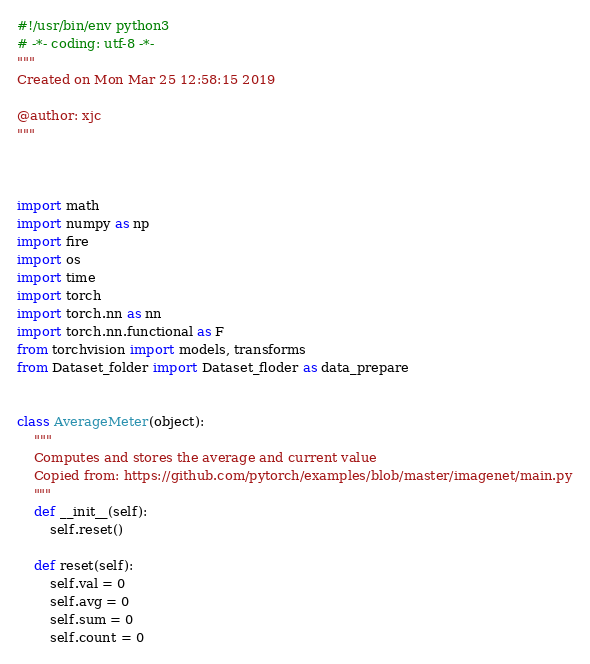<code> <loc_0><loc_0><loc_500><loc_500><_Python_>#!/usr/bin/env python3
# -*- coding: utf-8 -*-
"""
Created on Mon Mar 25 12:58:15 2019

@author: xjc
"""



import math
import numpy as np
import fire
import os
import time
import torch
import torch.nn as nn
import torch.nn.functional as F
from torchvision import models, transforms
from Dataset_folder import Dataset_floder as data_prepare


class AverageMeter(object):
    """
    Computes and stores the average and current value
    Copied from: https://github.com/pytorch/examples/blob/master/imagenet/main.py
    """
    def __init__(self):
        self.reset()

    def reset(self):
        self.val = 0
        self.avg = 0
        self.sum = 0
        self.count = 0
</code> 